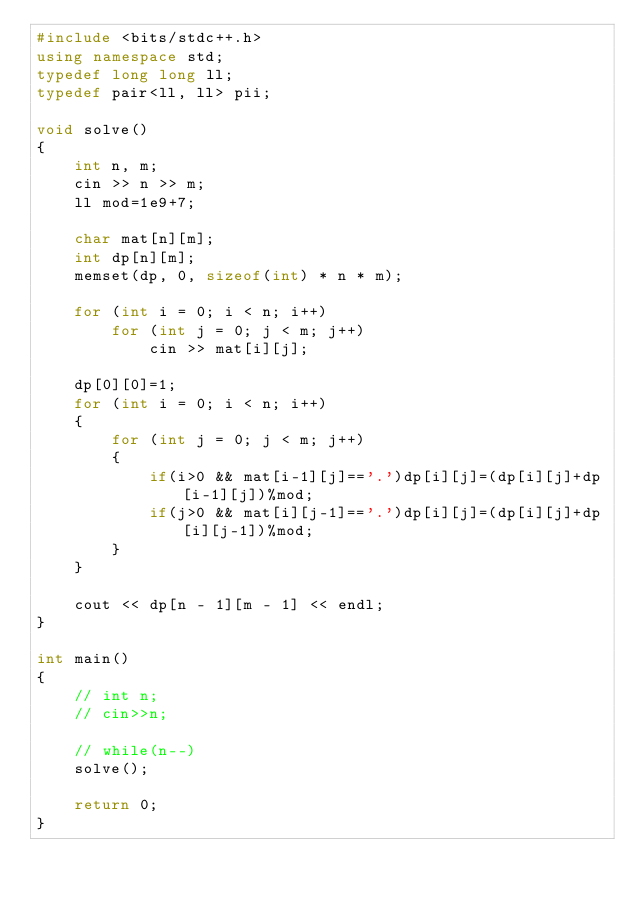Convert code to text. <code><loc_0><loc_0><loc_500><loc_500><_C++_>#include <bits/stdc++.h>
using namespace std;
typedef long long ll;
typedef pair<ll, ll> pii;

void solve()
{
    int n, m;
    cin >> n >> m;
    ll mod=1e9+7;

    char mat[n][m];
    int dp[n][m];
    memset(dp, 0, sizeof(int) * n * m);

    for (int i = 0; i < n; i++)
        for (int j = 0; j < m; j++)
            cin >> mat[i][j];

    dp[0][0]=1;
    for (int i = 0; i < n; i++)
    {
        for (int j = 0; j < m; j++)
        {
            if(i>0 && mat[i-1][j]=='.')dp[i][j]=(dp[i][j]+dp[i-1][j])%mod;
            if(j>0 && mat[i][j-1]=='.')dp[i][j]=(dp[i][j]+dp[i][j-1])%mod;
        }
    }

    cout << dp[n - 1][m - 1] << endl;
}

int main()
{
    // int n;
    // cin>>n;

    // while(n--)
    solve();

    return 0;
}</code> 